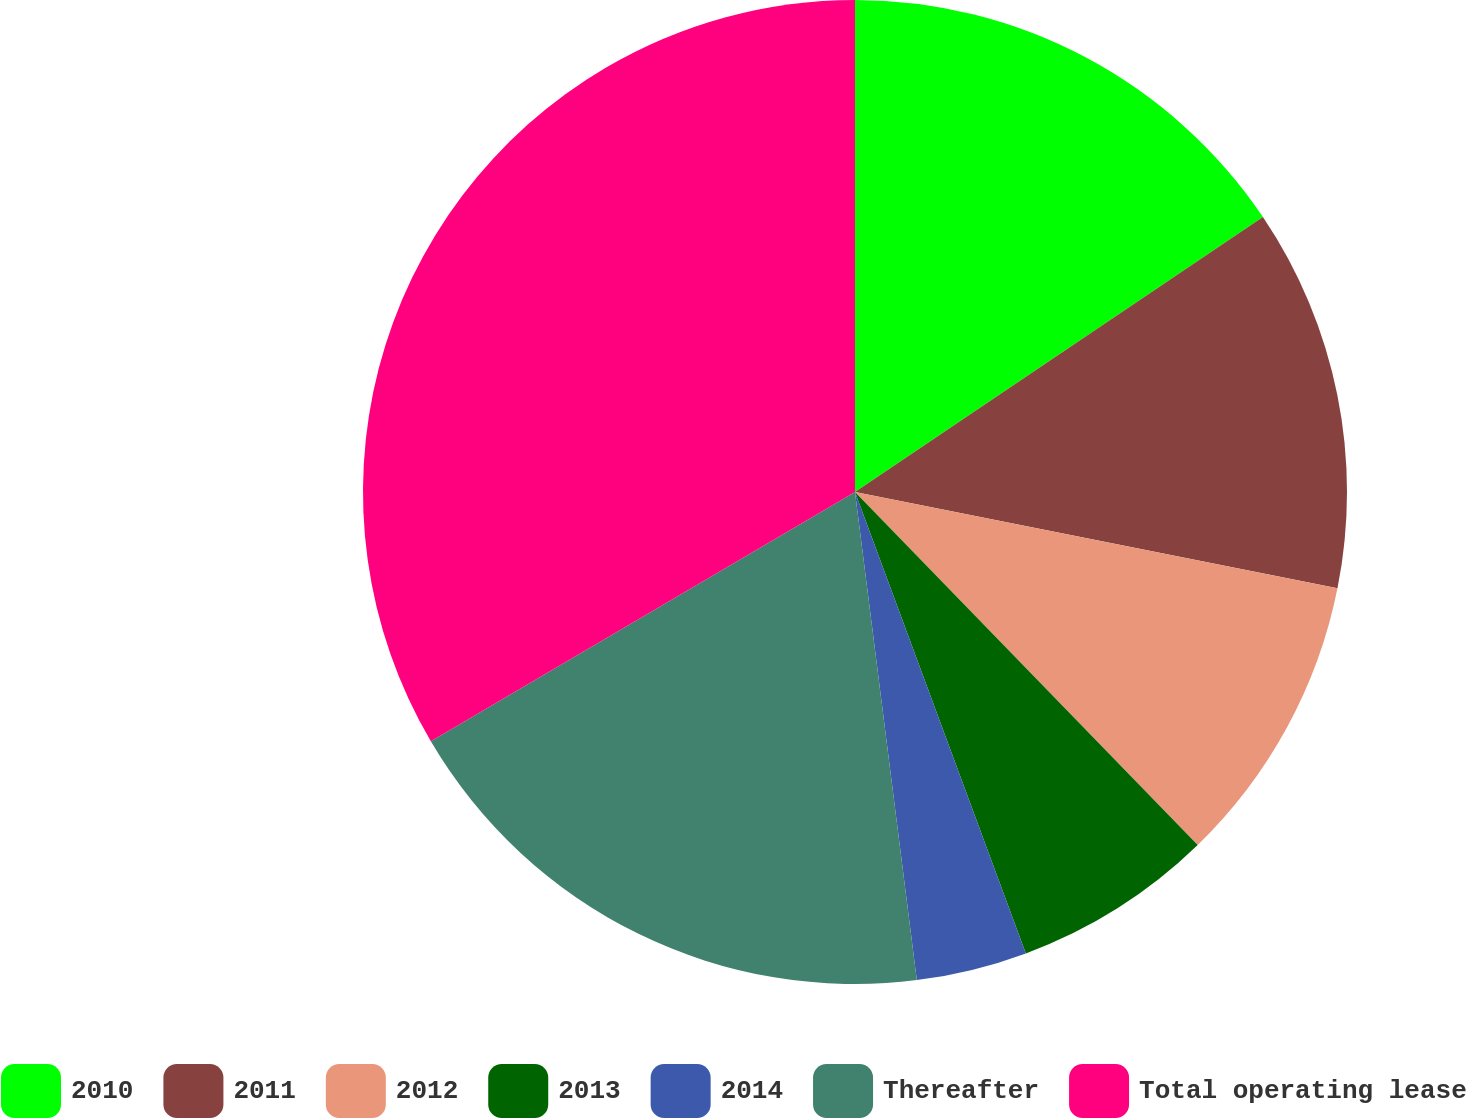<chart> <loc_0><loc_0><loc_500><loc_500><pie_chart><fcel>2010<fcel>2011<fcel>2012<fcel>2013<fcel>2014<fcel>Thereafter<fcel>Total operating lease<nl><fcel>15.56%<fcel>12.58%<fcel>9.6%<fcel>6.62%<fcel>3.64%<fcel>18.55%<fcel>33.46%<nl></chart> 